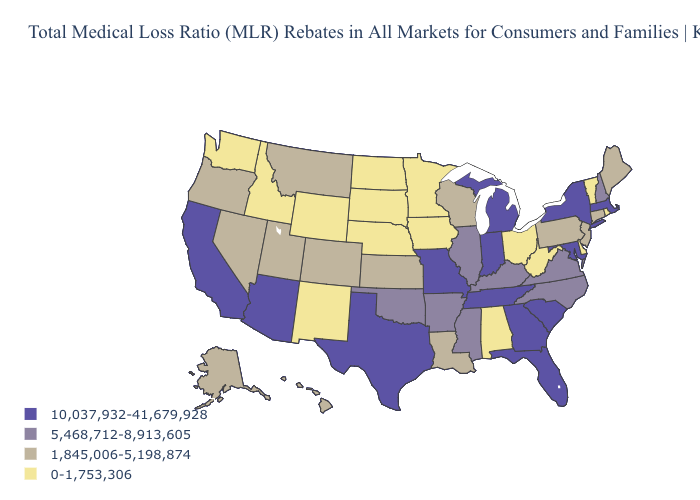What is the value of Iowa?
Concise answer only. 0-1,753,306. Name the states that have a value in the range 10,037,932-41,679,928?
Keep it brief. Arizona, California, Florida, Georgia, Indiana, Maryland, Massachusetts, Michigan, Missouri, New York, South Carolina, Tennessee, Texas. Name the states that have a value in the range 10,037,932-41,679,928?
Answer briefly. Arizona, California, Florida, Georgia, Indiana, Maryland, Massachusetts, Michigan, Missouri, New York, South Carolina, Tennessee, Texas. What is the value of Florida?
Concise answer only. 10,037,932-41,679,928. What is the value of Kansas?
Answer briefly. 1,845,006-5,198,874. Does Michigan have the lowest value in the USA?
Be succinct. No. What is the highest value in the USA?
Write a very short answer. 10,037,932-41,679,928. Does the first symbol in the legend represent the smallest category?
Be succinct. No. Name the states that have a value in the range 5,468,712-8,913,605?
Quick response, please. Arkansas, Illinois, Kentucky, Mississippi, New Hampshire, North Carolina, Oklahoma, Virginia. What is the lowest value in the USA?
Write a very short answer. 0-1,753,306. Does South Carolina have the highest value in the South?
Be succinct. Yes. What is the lowest value in states that border California?
Be succinct. 1,845,006-5,198,874. Which states have the lowest value in the West?
Keep it brief. Idaho, New Mexico, Washington, Wyoming. Among the states that border Connecticut , which have the highest value?
Be succinct. Massachusetts, New York. Which states have the lowest value in the USA?
Answer briefly. Alabama, Delaware, Idaho, Iowa, Minnesota, Nebraska, New Mexico, North Dakota, Ohio, Rhode Island, South Dakota, Vermont, Washington, West Virginia, Wyoming. 